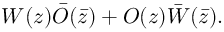Convert formula to latex. <formula><loc_0><loc_0><loc_500><loc_500>W ( z ) \bar { O } ( \bar { z } ) + O ( z ) \bar { W } ( \bar { z } ) .</formula> 